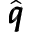Convert formula to latex. <formula><loc_0><loc_0><loc_500><loc_500>\hat { \pm b q }</formula> 